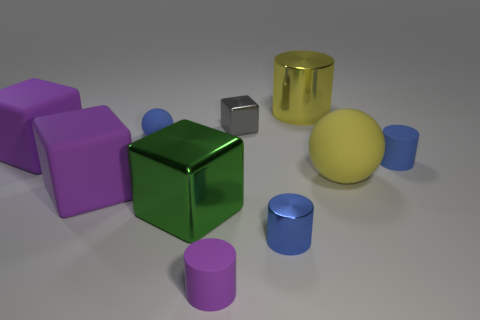How many other big blue things have the same shape as the blue shiny object?
Make the answer very short. 0. What is the material of the big purple cube in front of the big yellow sphere?
Keep it short and to the point. Rubber. Is the number of green metallic objects that are behind the large metallic block less than the number of large purple rubber spheres?
Your answer should be very brief. No. Does the tiny blue metal thing have the same shape as the tiny gray metal object?
Offer a very short reply. No. Is there anything else that has the same shape as the green object?
Keep it short and to the point. Yes. Is there a small purple metal thing?
Provide a succinct answer. No. Do the large yellow matte object and the shiny object that is behind the small gray shiny thing have the same shape?
Provide a short and direct response. No. The yellow thing that is behind the tiny gray block that is to the left of the small metal cylinder is made of what material?
Your response must be concise. Metal. The small sphere has what color?
Offer a very short reply. Blue. There is a matte cylinder behind the purple cylinder; is its color the same as the large metallic thing in front of the tiny ball?
Give a very brief answer. No. 